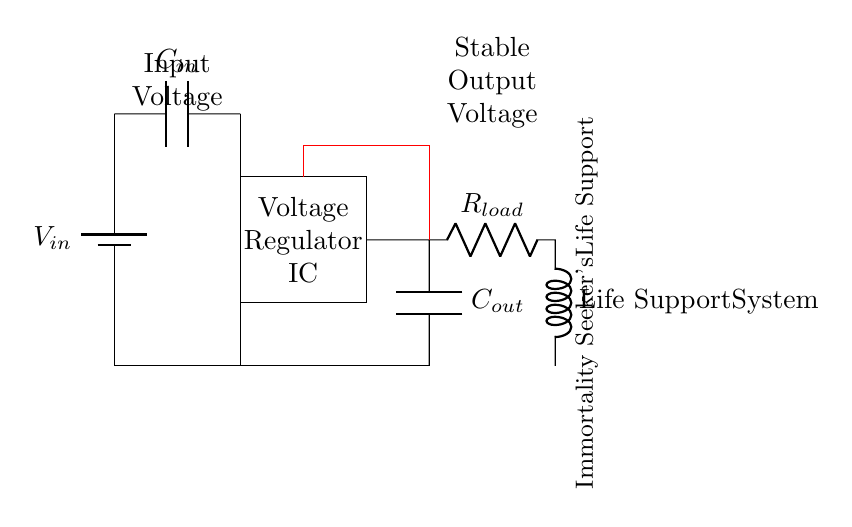What component provides input voltage? The component providing input voltage is the battery, which is labeled as V in the circuit. It delivers electrical energy to the circuit.
Answer: Battery What is the purpose of the voltage regulator IC? The voltage regulator IC is designed to maintain a stable output voltage despite variations in input voltage or load current, which is crucial for electronic devices like life-support systems needing reliable power.
Answer: Maintain stable voltage What capacitors are present in the circuit? The circuit contains two capacitors: one at the input labeled C in and another at the output labeled C out, which help filter voltage fluctuations.
Answer: C in and C out What does R load represent? R load represents the load resistance that the voltage regulator must supply current to; in this case, it is part of the life-support system, which is an essential application for stability.
Answer: Load resistance What happens if the input voltage decreases? If the input voltage decreases, the voltage regulator IC still attempts to provide a stable output voltage; however, if it drops below a certain level, the output may also decrease, potentially affecting the life-support system.
Answer: Output may decrease What is the role of the feedback connection? The feedback connection, shown in red, senses the output voltage and provides it back to the voltage regulator IC, allowing it to adjust operations to keep the output stable, ensuring reliability in life-support systems.
Answer: Stabilizes output voltage What does "Life Support System" signify in the circuit? "Life Support System" signifies that this circuit is crucial for providing stable power to essential medical or life-maintaining equipment, which emphasizes the circuit's importance for preserving life.
Answer: Critical application 